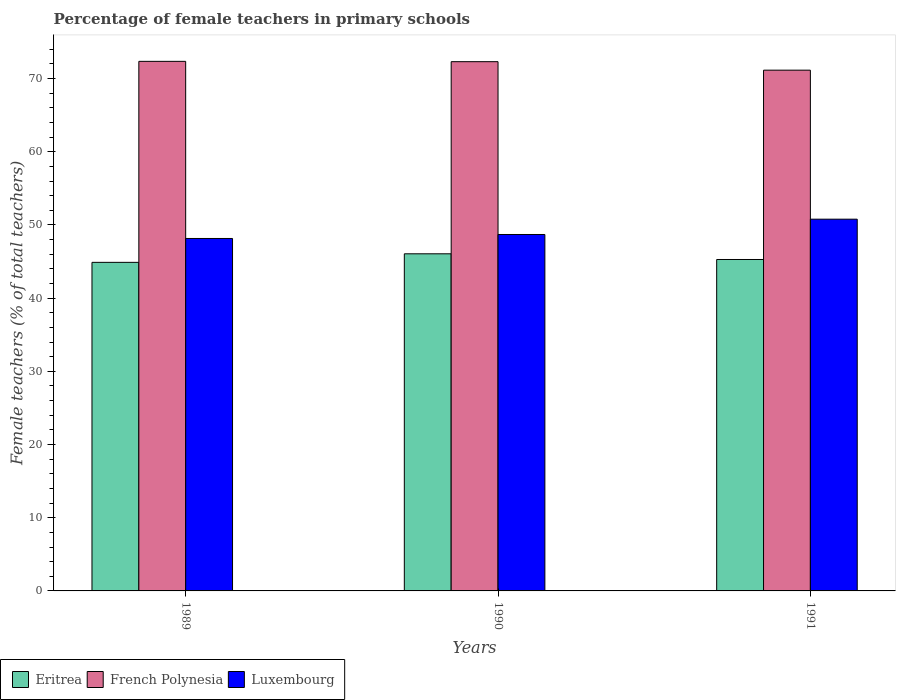How many groups of bars are there?
Provide a succinct answer. 3. How many bars are there on the 3rd tick from the left?
Offer a terse response. 3. How many bars are there on the 1st tick from the right?
Give a very brief answer. 3. In how many cases, is the number of bars for a given year not equal to the number of legend labels?
Make the answer very short. 0. What is the percentage of female teachers in Luxembourg in 1991?
Your response must be concise. 50.79. Across all years, what is the maximum percentage of female teachers in Luxembourg?
Ensure brevity in your answer.  50.79. Across all years, what is the minimum percentage of female teachers in Luxembourg?
Provide a succinct answer. 48.16. In which year was the percentage of female teachers in Eritrea maximum?
Ensure brevity in your answer.  1990. In which year was the percentage of female teachers in French Polynesia minimum?
Ensure brevity in your answer.  1991. What is the total percentage of female teachers in Luxembourg in the graph?
Give a very brief answer. 147.65. What is the difference between the percentage of female teachers in Luxembourg in 1989 and that in 1990?
Offer a terse response. -0.54. What is the difference between the percentage of female teachers in French Polynesia in 1989 and the percentage of female teachers in Luxembourg in 1991?
Give a very brief answer. 21.56. What is the average percentage of female teachers in Luxembourg per year?
Your answer should be compact. 49.22. In the year 1990, what is the difference between the percentage of female teachers in French Polynesia and percentage of female teachers in Eritrea?
Provide a succinct answer. 26.25. What is the ratio of the percentage of female teachers in French Polynesia in 1989 to that in 1990?
Offer a terse response. 1. Is the percentage of female teachers in Luxembourg in 1990 less than that in 1991?
Make the answer very short. Yes. Is the difference between the percentage of female teachers in French Polynesia in 1990 and 1991 greater than the difference between the percentage of female teachers in Eritrea in 1990 and 1991?
Offer a terse response. Yes. What is the difference between the highest and the second highest percentage of female teachers in Luxembourg?
Keep it short and to the point. 2.09. What is the difference between the highest and the lowest percentage of female teachers in French Polynesia?
Provide a short and direct response. 1.2. In how many years, is the percentage of female teachers in Eritrea greater than the average percentage of female teachers in Eritrea taken over all years?
Make the answer very short. 1. What does the 1st bar from the left in 1989 represents?
Your response must be concise. Eritrea. What does the 3rd bar from the right in 1990 represents?
Give a very brief answer. Eritrea. Are all the bars in the graph horizontal?
Your answer should be compact. No. How many years are there in the graph?
Your answer should be compact. 3. Does the graph contain any zero values?
Ensure brevity in your answer.  No. Does the graph contain grids?
Ensure brevity in your answer.  No. Where does the legend appear in the graph?
Offer a very short reply. Bottom left. How are the legend labels stacked?
Keep it short and to the point. Horizontal. What is the title of the graph?
Offer a very short reply. Percentage of female teachers in primary schools. What is the label or title of the Y-axis?
Your answer should be very brief. Female teachers (% of total teachers). What is the Female teachers (% of total teachers) of Eritrea in 1989?
Your answer should be very brief. 44.89. What is the Female teachers (% of total teachers) in French Polynesia in 1989?
Ensure brevity in your answer.  72.36. What is the Female teachers (% of total teachers) in Luxembourg in 1989?
Provide a succinct answer. 48.16. What is the Female teachers (% of total teachers) in Eritrea in 1990?
Your response must be concise. 46.06. What is the Female teachers (% of total teachers) of French Polynesia in 1990?
Provide a short and direct response. 72.31. What is the Female teachers (% of total teachers) in Luxembourg in 1990?
Your answer should be very brief. 48.7. What is the Female teachers (% of total teachers) in Eritrea in 1991?
Provide a short and direct response. 45.28. What is the Female teachers (% of total teachers) in French Polynesia in 1991?
Provide a short and direct response. 71.15. What is the Female teachers (% of total teachers) of Luxembourg in 1991?
Keep it short and to the point. 50.79. Across all years, what is the maximum Female teachers (% of total teachers) of Eritrea?
Your answer should be compact. 46.06. Across all years, what is the maximum Female teachers (% of total teachers) in French Polynesia?
Your response must be concise. 72.36. Across all years, what is the maximum Female teachers (% of total teachers) in Luxembourg?
Make the answer very short. 50.79. Across all years, what is the minimum Female teachers (% of total teachers) in Eritrea?
Offer a very short reply. 44.89. Across all years, what is the minimum Female teachers (% of total teachers) in French Polynesia?
Give a very brief answer. 71.15. Across all years, what is the minimum Female teachers (% of total teachers) of Luxembourg?
Provide a succinct answer. 48.16. What is the total Female teachers (% of total teachers) in Eritrea in the graph?
Offer a terse response. 136.24. What is the total Female teachers (% of total teachers) of French Polynesia in the graph?
Make the answer very short. 215.83. What is the total Female teachers (% of total teachers) of Luxembourg in the graph?
Provide a short and direct response. 147.65. What is the difference between the Female teachers (% of total teachers) of Eritrea in 1989 and that in 1990?
Ensure brevity in your answer.  -1.17. What is the difference between the Female teachers (% of total teachers) in French Polynesia in 1989 and that in 1990?
Offer a terse response. 0.04. What is the difference between the Female teachers (% of total teachers) in Luxembourg in 1989 and that in 1990?
Ensure brevity in your answer.  -0.54. What is the difference between the Female teachers (% of total teachers) in Eritrea in 1989 and that in 1991?
Give a very brief answer. -0.39. What is the difference between the Female teachers (% of total teachers) of French Polynesia in 1989 and that in 1991?
Your answer should be very brief. 1.2. What is the difference between the Female teachers (% of total teachers) in Luxembourg in 1989 and that in 1991?
Your response must be concise. -2.64. What is the difference between the Female teachers (% of total teachers) of Eritrea in 1990 and that in 1991?
Provide a succinct answer. 0.78. What is the difference between the Female teachers (% of total teachers) of French Polynesia in 1990 and that in 1991?
Give a very brief answer. 1.16. What is the difference between the Female teachers (% of total teachers) in Luxembourg in 1990 and that in 1991?
Your answer should be very brief. -2.09. What is the difference between the Female teachers (% of total teachers) in Eritrea in 1989 and the Female teachers (% of total teachers) in French Polynesia in 1990?
Your response must be concise. -27.42. What is the difference between the Female teachers (% of total teachers) of Eritrea in 1989 and the Female teachers (% of total teachers) of Luxembourg in 1990?
Keep it short and to the point. -3.81. What is the difference between the Female teachers (% of total teachers) in French Polynesia in 1989 and the Female teachers (% of total teachers) in Luxembourg in 1990?
Offer a very short reply. 23.66. What is the difference between the Female teachers (% of total teachers) in Eritrea in 1989 and the Female teachers (% of total teachers) in French Polynesia in 1991?
Offer a very short reply. -26.26. What is the difference between the Female teachers (% of total teachers) in Eritrea in 1989 and the Female teachers (% of total teachers) in Luxembourg in 1991?
Your response must be concise. -5.9. What is the difference between the Female teachers (% of total teachers) of French Polynesia in 1989 and the Female teachers (% of total teachers) of Luxembourg in 1991?
Offer a terse response. 21.56. What is the difference between the Female teachers (% of total teachers) in Eritrea in 1990 and the Female teachers (% of total teachers) in French Polynesia in 1991?
Provide a succinct answer. -25.09. What is the difference between the Female teachers (% of total teachers) of Eritrea in 1990 and the Female teachers (% of total teachers) of Luxembourg in 1991?
Keep it short and to the point. -4.73. What is the difference between the Female teachers (% of total teachers) of French Polynesia in 1990 and the Female teachers (% of total teachers) of Luxembourg in 1991?
Your answer should be very brief. 21.52. What is the average Female teachers (% of total teachers) in Eritrea per year?
Keep it short and to the point. 45.41. What is the average Female teachers (% of total teachers) of French Polynesia per year?
Your answer should be compact. 71.94. What is the average Female teachers (% of total teachers) in Luxembourg per year?
Make the answer very short. 49.22. In the year 1989, what is the difference between the Female teachers (% of total teachers) of Eritrea and Female teachers (% of total teachers) of French Polynesia?
Keep it short and to the point. -27.46. In the year 1989, what is the difference between the Female teachers (% of total teachers) in Eritrea and Female teachers (% of total teachers) in Luxembourg?
Give a very brief answer. -3.26. In the year 1989, what is the difference between the Female teachers (% of total teachers) in French Polynesia and Female teachers (% of total teachers) in Luxembourg?
Provide a succinct answer. 24.2. In the year 1990, what is the difference between the Female teachers (% of total teachers) in Eritrea and Female teachers (% of total teachers) in French Polynesia?
Give a very brief answer. -26.25. In the year 1990, what is the difference between the Female teachers (% of total teachers) in Eritrea and Female teachers (% of total teachers) in Luxembourg?
Provide a succinct answer. -2.64. In the year 1990, what is the difference between the Female teachers (% of total teachers) of French Polynesia and Female teachers (% of total teachers) of Luxembourg?
Provide a short and direct response. 23.61. In the year 1991, what is the difference between the Female teachers (% of total teachers) in Eritrea and Female teachers (% of total teachers) in French Polynesia?
Make the answer very short. -25.87. In the year 1991, what is the difference between the Female teachers (% of total teachers) in Eritrea and Female teachers (% of total teachers) in Luxembourg?
Your answer should be very brief. -5.51. In the year 1991, what is the difference between the Female teachers (% of total teachers) of French Polynesia and Female teachers (% of total teachers) of Luxembourg?
Give a very brief answer. 20.36. What is the ratio of the Female teachers (% of total teachers) in Eritrea in 1989 to that in 1990?
Keep it short and to the point. 0.97. What is the ratio of the Female teachers (% of total teachers) in French Polynesia in 1989 to that in 1990?
Keep it short and to the point. 1. What is the ratio of the Female teachers (% of total teachers) of Luxembourg in 1989 to that in 1990?
Offer a terse response. 0.99. What is the ratio of the Female teachers (% of total teachers) in French Polynesia in 1989 to that in 1991?
Offer a terse response. 1.02. What is the ratio of the Female teachers (% of total teachers) of Luxembourg in 1989 to that in 1991?
Provide a short and direct response. 0.95. What is the ratio of the Female teachers (% of total teachers) of Eritrea in 1990 to that in 1991?
Your answer should be very brief. 1.02. What is the ratio of the Female teachers (% of total teachers) of French Polynesia in 1990 to that in 1991?
Offer a terse response. 1.02. What is the ratio of the Female teachers (% of total teachers) in Luxembourg in 1990 to that in 1991?
Offer a very short reply. 0.96. What is the difference between the highest and the second highest Female teachers (% of total teachers) in Eritrea?
Offer a terse response. 0.78. What is the difference between the highest and the second highest Female teachers (% of total teachers) in French Polynesia?
Your answer should be compact. 0.04. What is the difference between the highest and the second highest Female teachers (% of total teachers) of Luxembourg?
Your response must be concise. 2.09. What is the difference between the highest and the lowest Female teachers (% of total teachers) in Eritrea?
Give a very brief answer. 1.17. What is the difference between the highest and the lowest Female teachers (% of total teachers) in French Polynesia?
Offer a very short reply. 1.2. What is the difference between the highest and the lowest Female teachers (% of total teachers) in Luxembourg?
Provide a short and direct response. 2.64. 